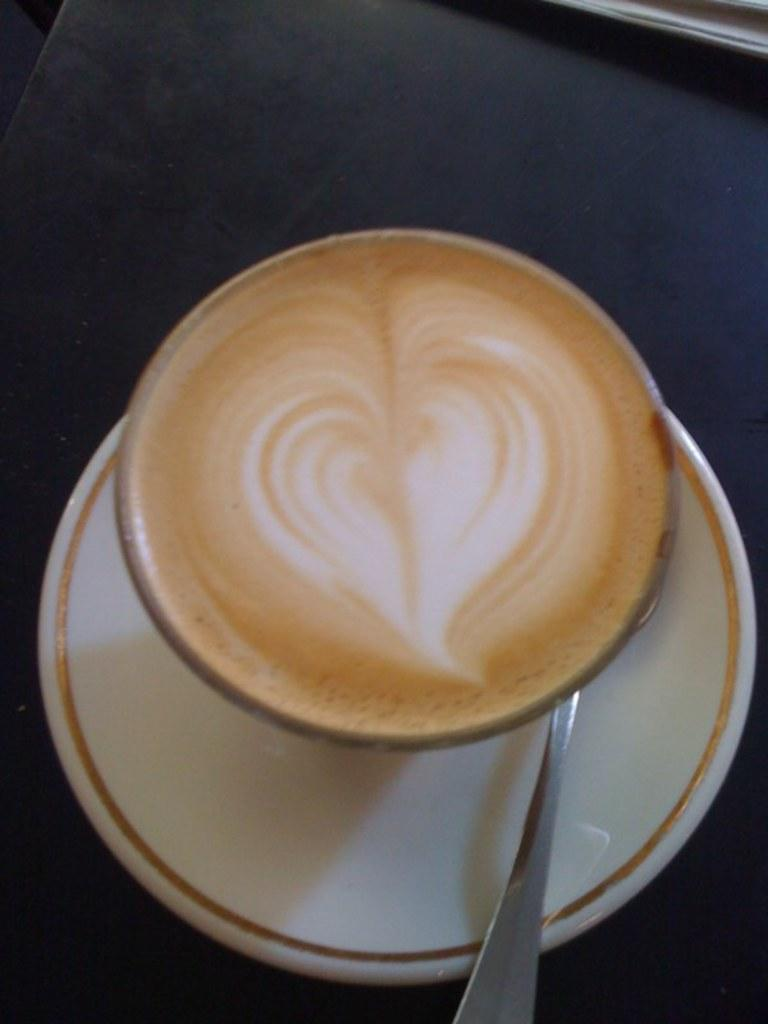What is in the cup that is visible in the image? There is a cup with coffee in the image. What other items can be seen in the image related to the coffee? There is a spoon on a saucer visible in the image. Where are the cup, spoon, and saucer located in the image? The cup, spoon, and saucer are on a platform in the image. What can be seen in the top right corner of the image? There is an object in the top right corner of the image. What type of reaction does the coffee have to the clouds in the image? There are no clouds present in the image, so the coffee cannot have a reaction to them. How does the coffee affect the stomach in the image? The image does not show any stomach or person consuming the coffee, so we cannot determine how it affects the stomach. 